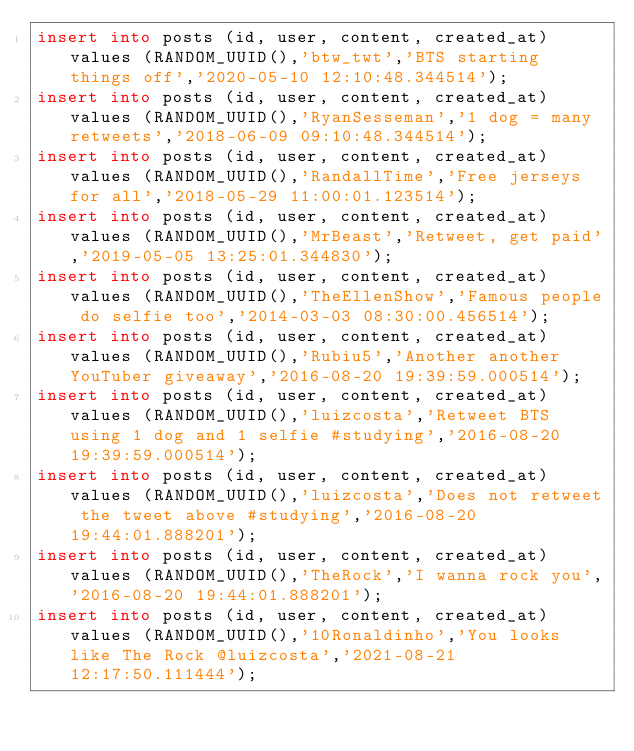Convert code to text. <code><loc_0><loc_0><loc_500><loc_500><_SQL_>insert into posts (id, user, content, created_at) values (RANDOM_UUID(),'btw_twt','BTS starting things off','2020-05-10 12:10:48.344514');
insert into posts (id, user, content, created_at) values (RANDOM_UUID(),'RyanSesseman','1 dog = many retweets','2018-06-09 09:10:48.344514');
insert into posts (id, user, content, created_at) values (RANDOM_UUID(),'RandallTime','Free jerseys for all','2018-05-29 11:00:01.123514');
insert into posts (id, user, content, created_at) values (RANDOM_UUID(),'MrBeast','Retweet, get paid','2019-05-05 13:25:01.344830');
insert into posts (id, user, content, created_at) values (RANDOM_UUID(),'TheEllenShow','Famous people do selfie too','2014-03-03 08:30:00.456514');
insert into posts (id, user, content, created_at) values (RANDOM_UUID(),'Rubiu5','Another another YouTuber giveaway','2016-08-20 19:39:59.000514');
insert into posts (id, user, content, created_at) values (RANDOM_UUID(),'luizcosta','Retweet BTS using 1 dog and 1 selfie #studying','2016-08-20 19:39:59.000514');
insert into posts (id, user, content, created_at) values (RANDOM_UUID(),'luizcosta','Does not retweet the tweet above #studying','2016-08-20 19:44:01.888201');
insert into posts (id, user, content, created_at) values (RANDOM_UUID(),'TheRock','I wanna rock you','2016-08-20 19:44:01.888201');
insert into posts (id, user, content, created_at) values (RANDOM_UUID(),'10Ronaldinho','You looks like The Rock @luizcosta','2021-08-21 12:17:50.111444');</code> 